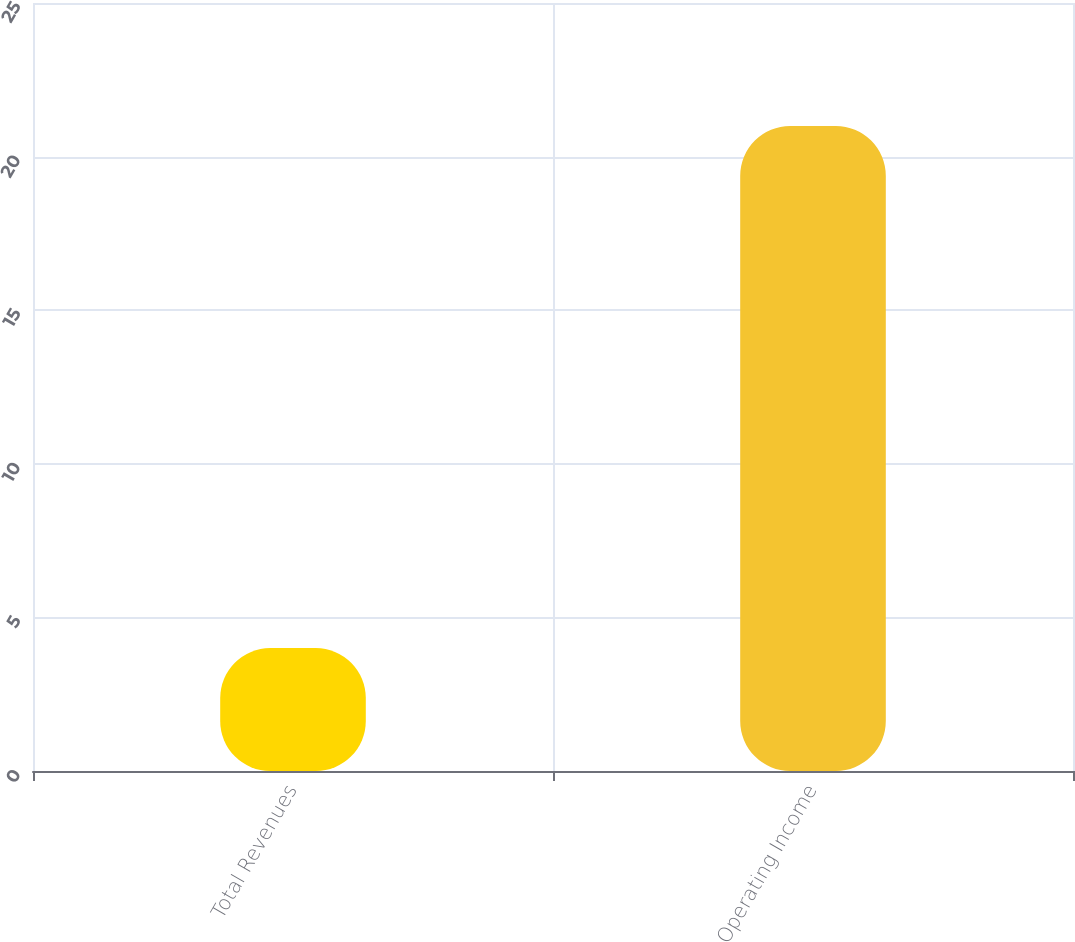Convert chart to OTSL. <chart><loc_0><loc_0><loc_500><loc_500><bar_chart><fcel>Total Revenues<fcel>Operating Income<nl><fcel>4<fcel>21<nl></chart> 